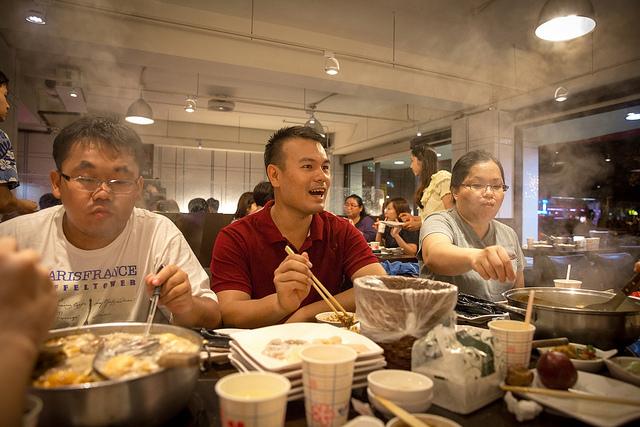Is this dining room and a house?
Answer briefly. No. What type of utensils are being used?
Concise answer only. Chopsticks. What are they eating?
Short answer required. Chinese food. How many cups are in this photo?
Be succinct. 4. 